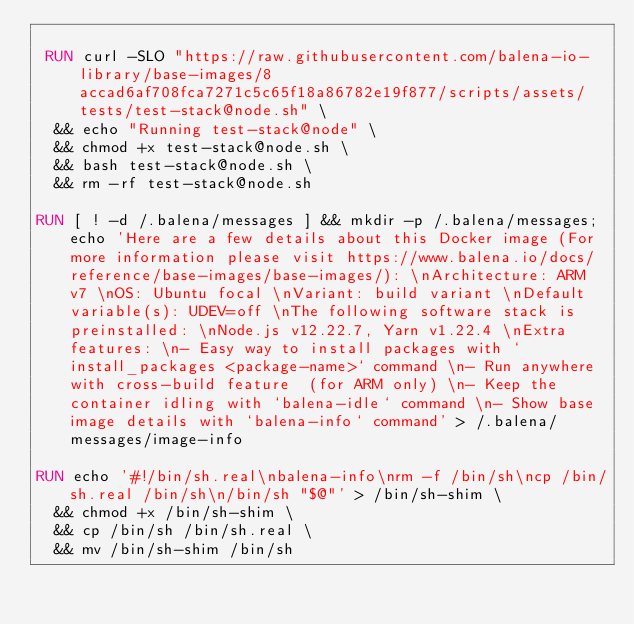Convert code to text. <code><loc_0><loc_0><loc_500><loc_500><_Dockerfile_>
 RUN curl -SLO "https://raw.githubusercontent.com/balena-io-library/base-images/8accad6af708fca7271c5c65f18a86782e19f877/scripts/assets/tests/test-stack@node.sh" \
  && echo "Running test-stack@node" \
  && chmod +x test-stack@node.sh \
  && bash test-stack@node.sh \
  && rm -rf test-stack@node.sh 

RUN [ ! -d /.balena/messages ] && mkdir -p /.balena/messages; echo 'Here are a few details about this Docker image (For more information please visit https://www.balena.io/docs/reference/base-images/base-images/): \nArchitecture: ARM v7 \nOS: Ubuntu focal \nVariant: build variant \nDefault variable(s): UDEV=off \nThe following software stack is preinstalled: \nNode.js v12.22.7, Yarn v1.22.4 \nExtra features: \n- Easy way to install packages with `install_packages <package-name>` command \n- Run anywhere with cross-build feature  (for ARM only) \n- Keep the container idling with `balena-idle` command \n- Show base image details with `balena-info` command' > /.balena/messages/image-info

RUN echo '#!/bin/sh.real\nbalena-info\nrm -f /bin/sh\ncp /bin/sh.real /bin/sh\n/bin/sh "$@"' > /bin/sh-shim \
	&& chmod +x /bin/sh-shim \
	&& cp /bin/sh /bin/sh.real \
	&& mv /bin/sh-shim /bin/sh</code> 